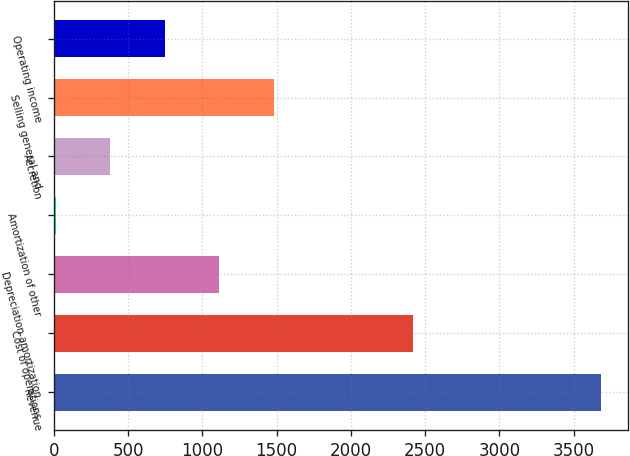Convert chart to OTSL. <chart><loc_0><loc_0><loc_500><loc_500><bar_chart><fcel>Revenue<fcel>Cost of operations<fcel>Depreciation amortization<fcel>Amortization of other<fcel>Accretion<fcel>Selling general and<fcel>Operating income<nl><fcel>3685.1<fcel>2416.7<fcel>1113.79<fcel>11.8<fcel>379.13<fcel>1481.12<fcel>746.46<nl></chart> 